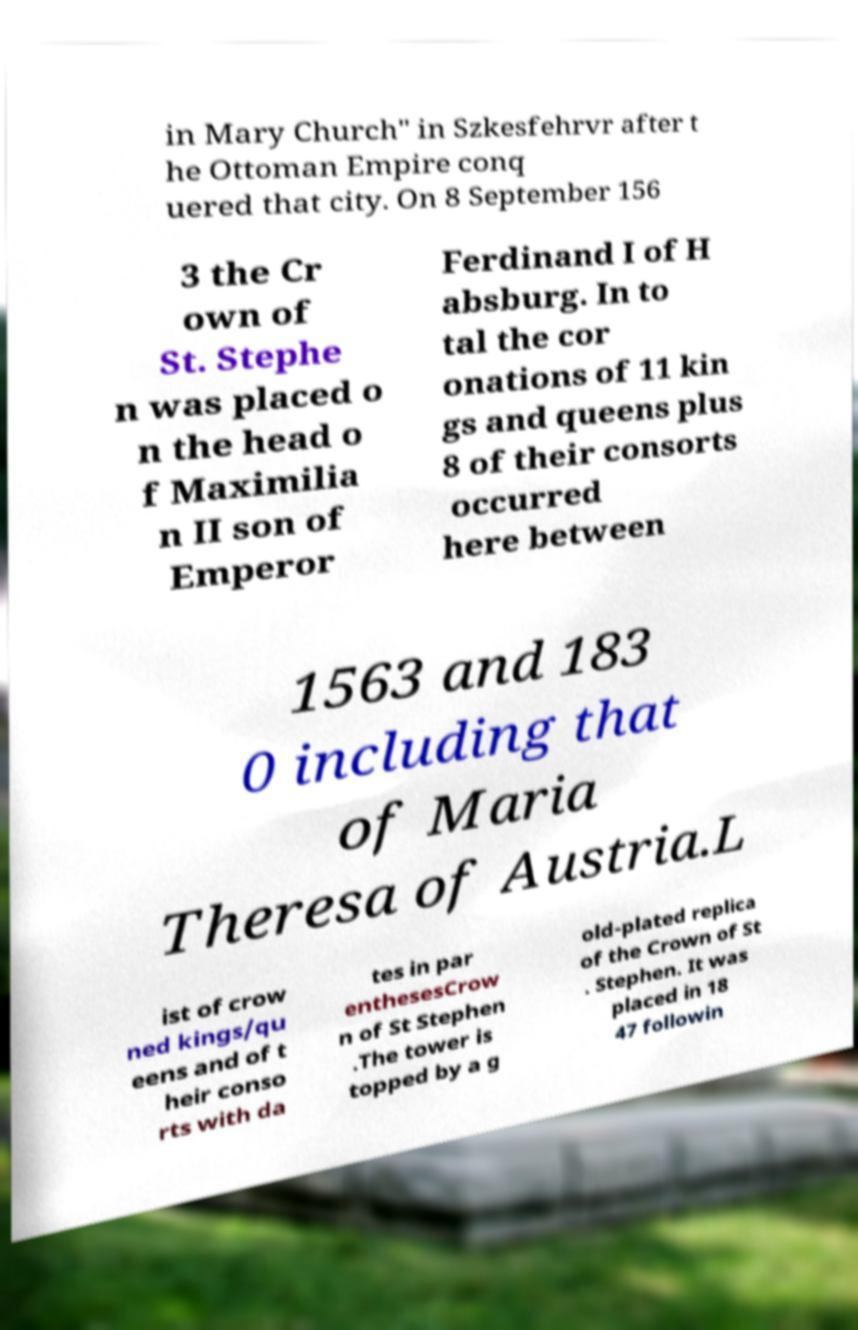Can you read and provide the text displayed in the image?This photo seems to have some interesting text. Can you extract and type it out for me? in Mary Church" in Szkesfehrvr after t he Ottoman Empire conq uered that city. On 8 September 156 3 the Cr own of St. Stephe n was placed o n the head o f Maximilia n II son of Emperor Ferdinand I of H absburg. In to tal the cor onations of 11 kin gs and queens plus 8 of their consorts occurred here between 1563 and 183 0 including that of Maria Theresa of Austria.L ist of crow ned kings/qu eens and of t heir conso rts with da tes in par enthesesCrow n of St Stephen .The tower is topped by a g old-plated replica of the Crown of St . Stephen. It was placed in 18 47 followin 